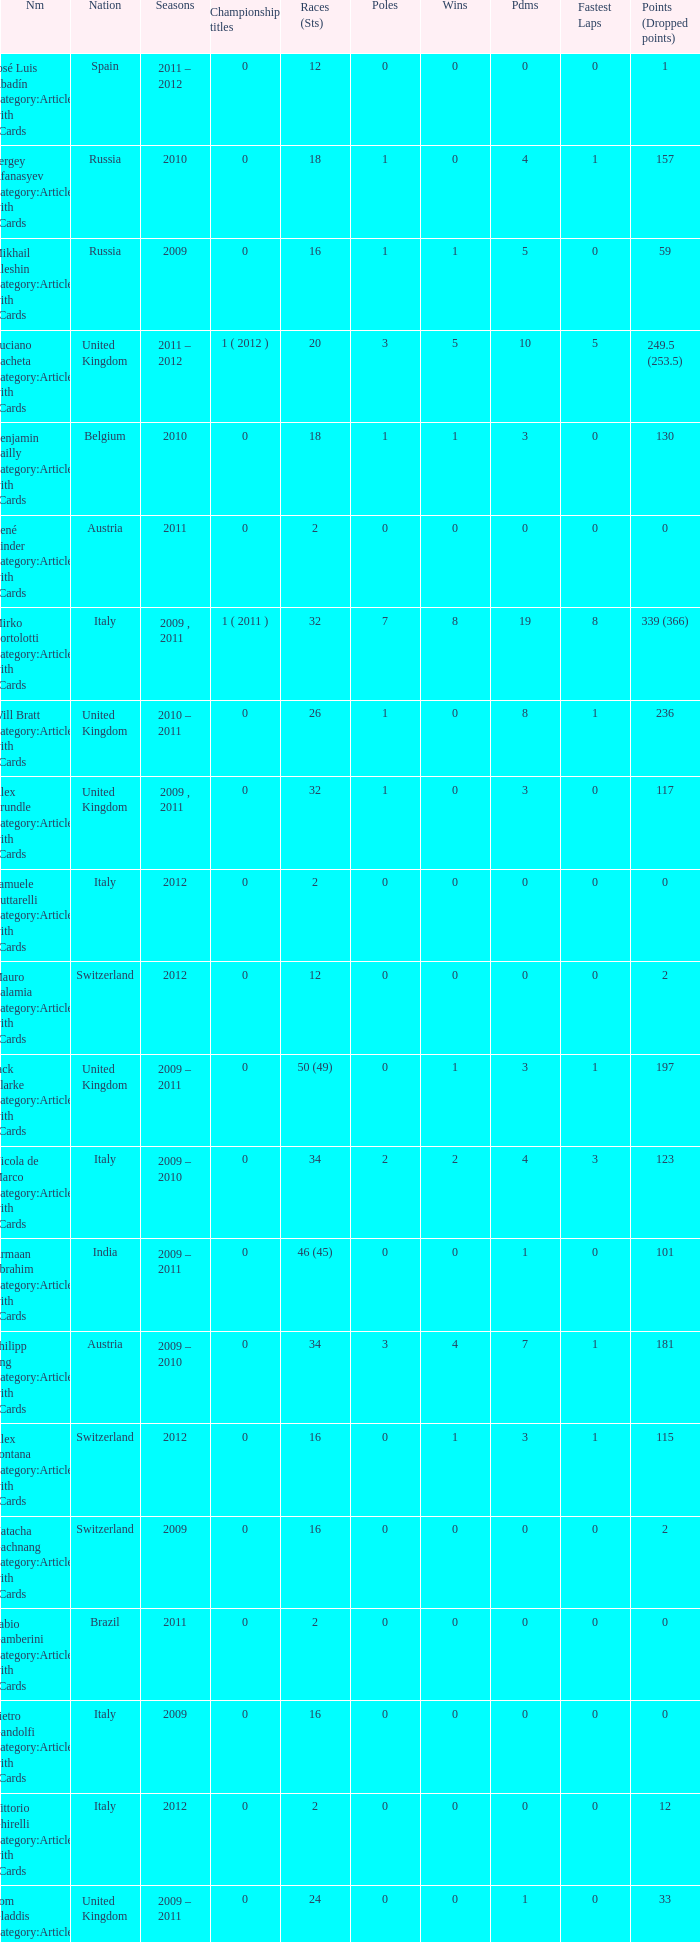What was the least amount of wins? 0.0. 